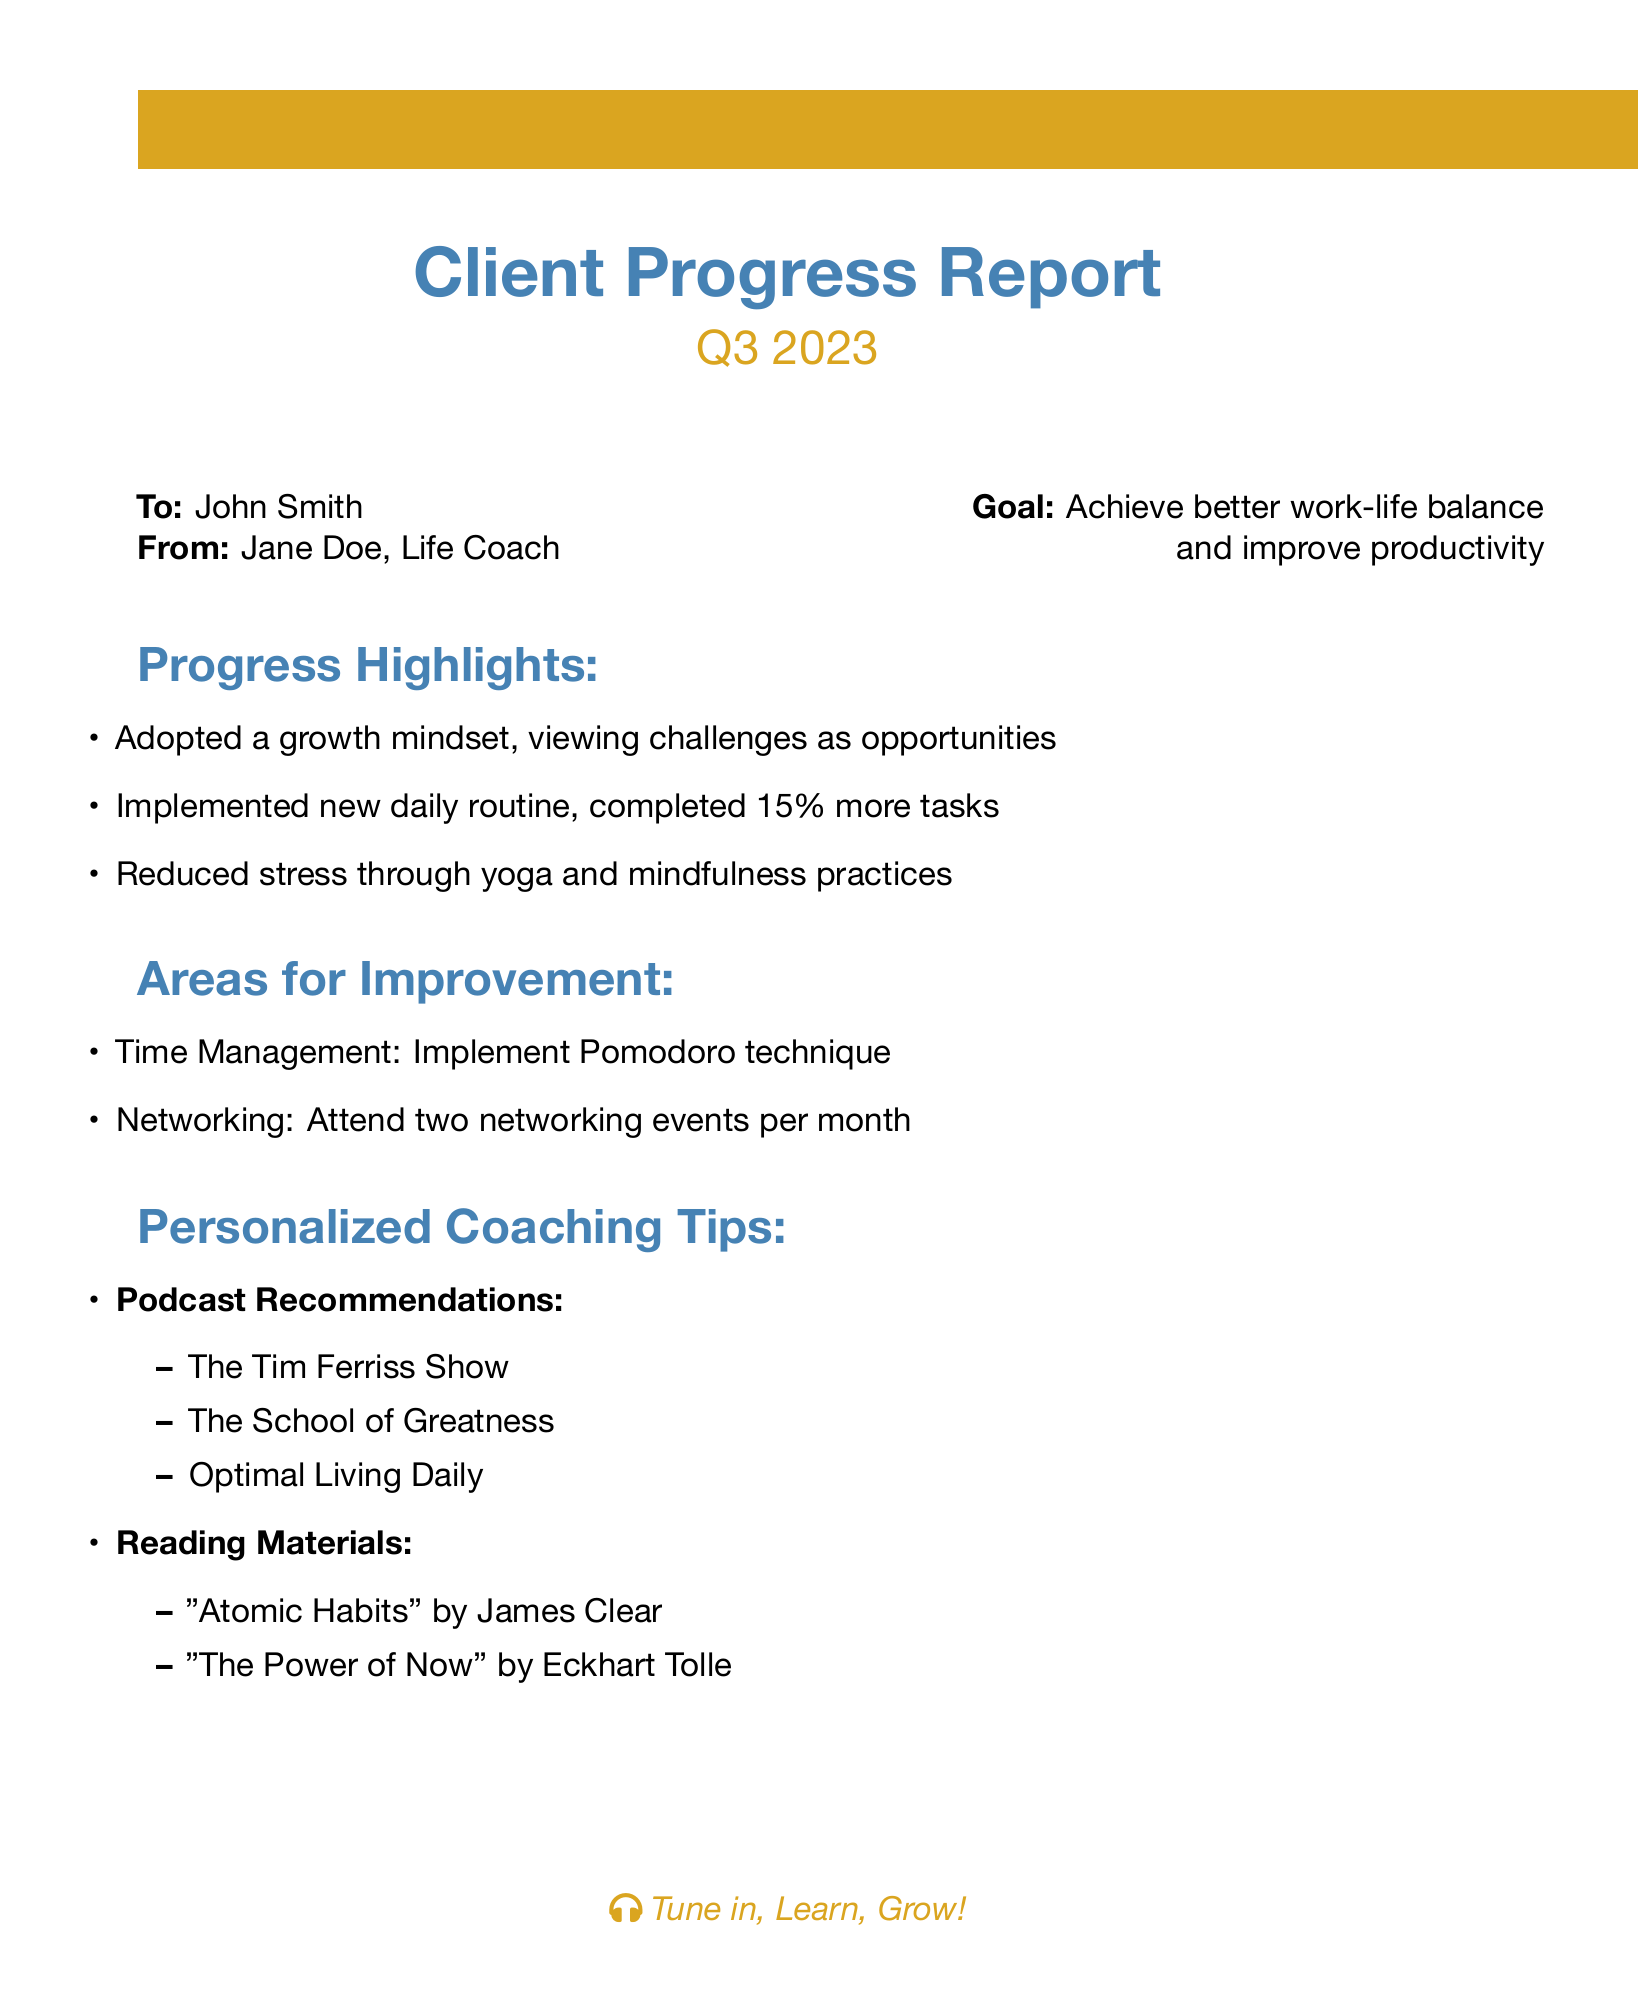What is the client's name? The client's name is mentioned at the beginning of the document under "To:", which is John Smith.
Answer: John Smith What is the report for? The report is specifically for the third quarter of 2023, as indicated in the title.
Answer: Q3 2023 What is the main goal stated in the report? The main goal is listed in the "From" section and is to achieve better work-life balance and improve productivity.
Answer: Achieve better work-life balance and improve productivity How much more tasks did the client complete? The report states that the client completed 15% more tasks, which is found in the "Progress Highlights" section.
Answer: 15% List one area for improvement mentioned in the report. One of the areas for improvement is time management, specifically suggesting the Pomodoro technique.
Answer: Time Management Which podcast is recommended in the coaching tips? The document lists several podcasts, one of which is "The Tim Ferriss Show."
Answer: The Tim Ferriss Show Who is the author of the report? The author is mentioned in the "From" section of the document, which states Jane Doe.
Answer: Jane Doe What practice did the client use to reduce stress? The report mentions yoga and mindfulness practices as ways to reduce stress.
Answer: Yoga and mindfulness practices 